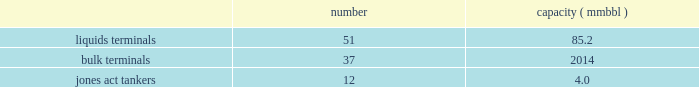In direct competition with other co2 pipelines .
We also compete with other interest owners in the mcelmo dome unit and the bravo dome unit for transportation of co2 to the denver city , texas market area .
Terminals our terminals segment includes the operations of our refined petroleum product , crude oil , chemical , ethanol and other liquid terminal facilities ( other than those included in the products pipelines segment ) and all of our coal , petroleum coke , fertilizer , steel , ores and other dry-bulk terminal facilities .
Our terminals are located throughout the u.s .
And in portions of canada .
We believe the location of our facilities and our ability to provide flexibility to customers help attract new and retain existing customers at our terminals and provide expansion opportunities .
We often classify our terminal operations based on the handling of either liquids or dry-bulk material products .
In addition , terminals 2019 marine operations include jones act qualified product tankers that provide marine transportation of crude oil , condensate and refined petroleum products in the u.s .
The following summarizes our terminals segment assets , as of december 31 , 2016 : number capacity ( mmbbl ) .
Competition we are one of the largest independent operators of liquids terminals in north america , based on barrels of liquids terminaling capacity .
Our liquids terminals compete with other publicly or privately held independent liquids terminals , and terminals owned by oil , chemical , pipeline , and refining companies .
Our bulk terminals compete with numerous independent terminal operators , terminals owned by producers and distributors of bulk commodities , stevedoring companies and other industrial companies opting not to outsource terminaling services .
In some locations , competitors are smaller , independent operators with lower cost structures .
Our jones act qualified product tankers compete with other jones act qualified vessel fleets. .
What is the average capacity in mmbbl of jones act tankers? 
Computations: (4 / 12)
Answer: 0.33333. 